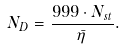Convert formula to latex. <formula><loc_0><loc_0><loc_500><loc_500>N _ { D } = \frac { 9 9 9 \cdot N _ { s t } } { \bar { \eta } } .</formula> 